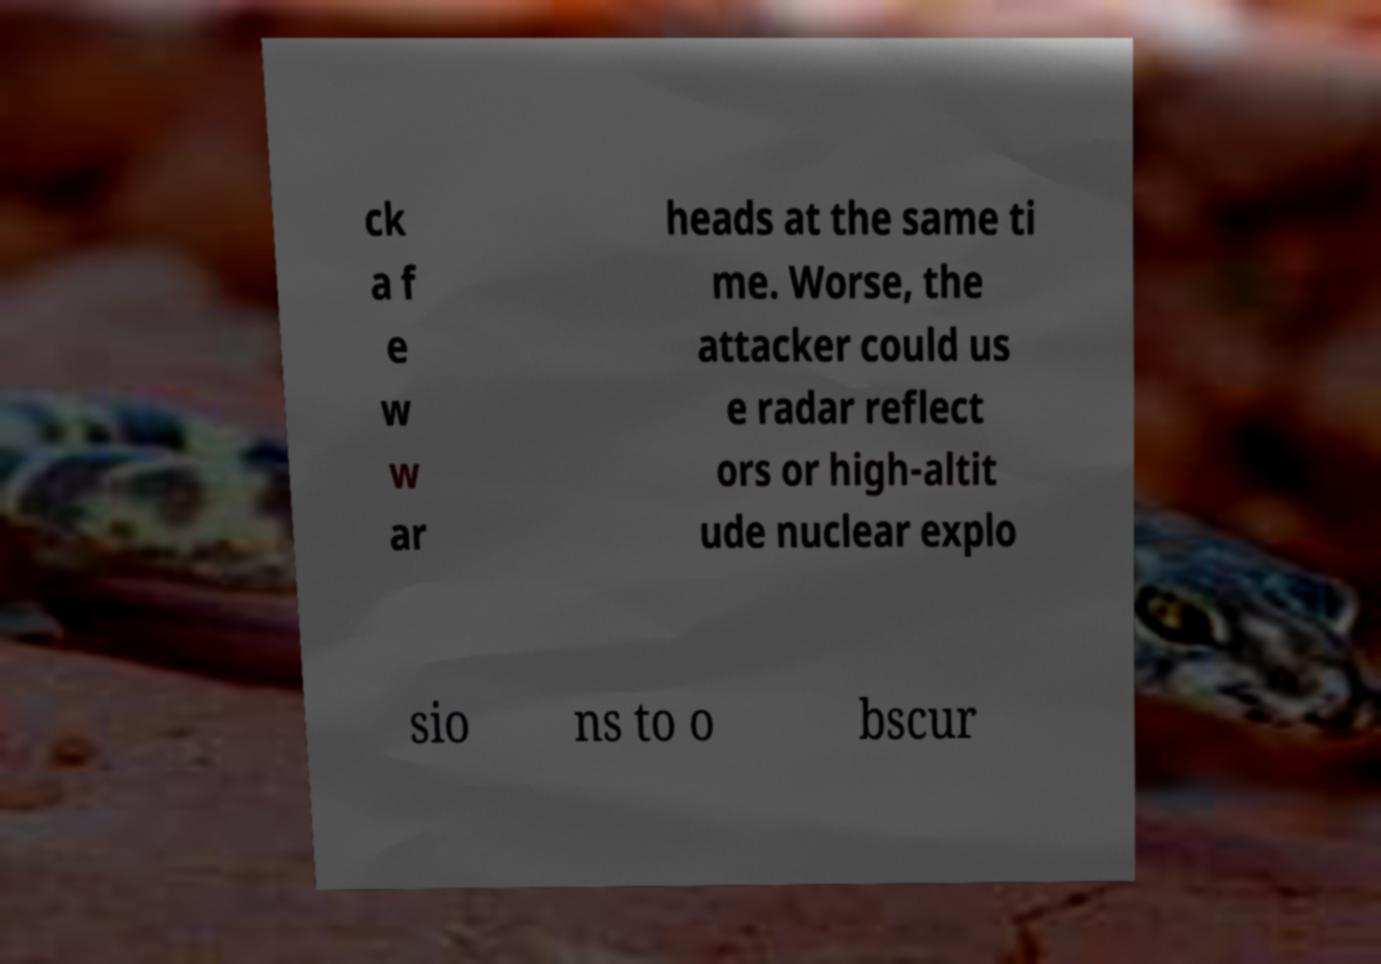What messages or text are displayed in this image? I need them in a readable, typed format. ck a f e w w ar heads at the same ti me. Worse, the attacker could us e radar reflect ors or high-altit ude nuclear explo sio ns to o bscur 